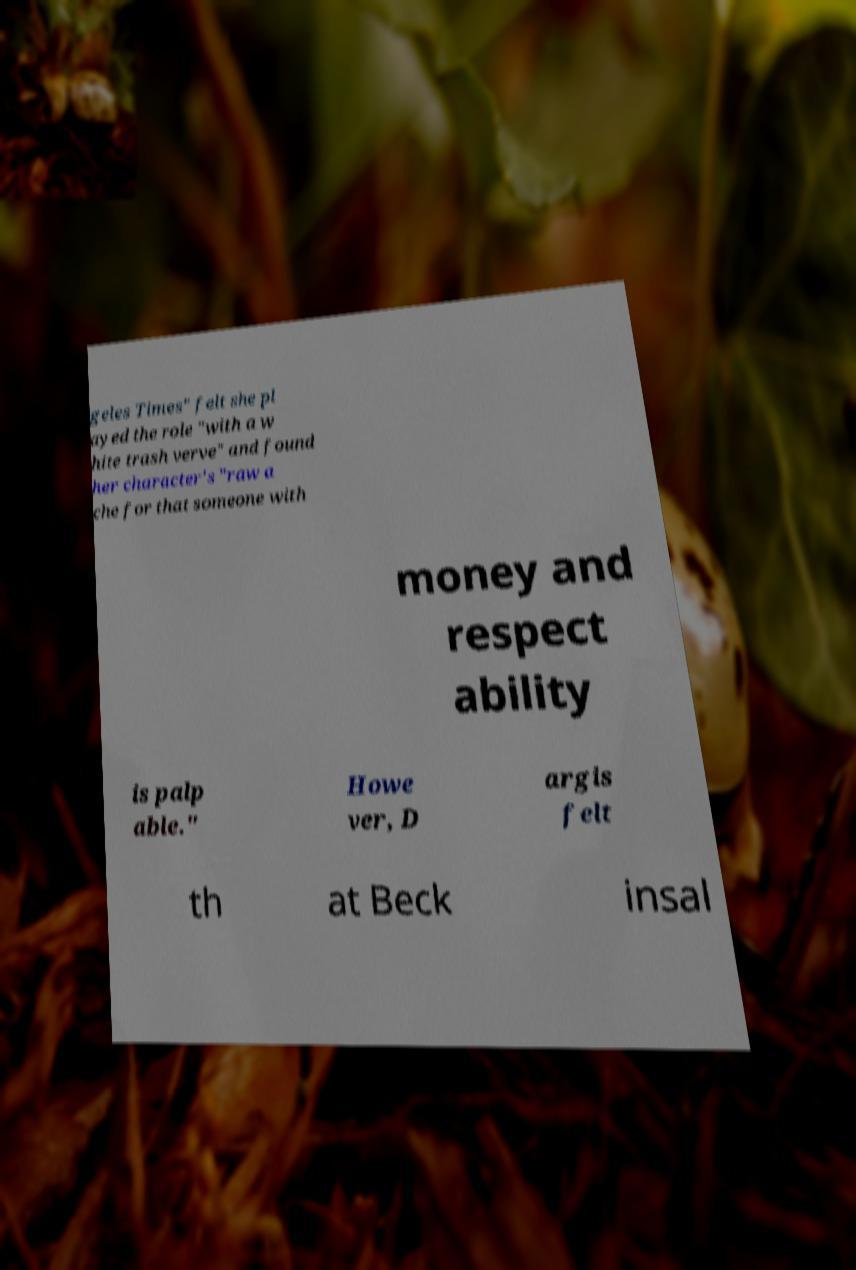Please identify and transcribe the text found in this image. geles Times" felt she pl ayed the role "with a w hite trash verve" and found her character's "raw a che for that someone with money and respect ability is palp able." Howe ver, D argis felt th at Beck insal 